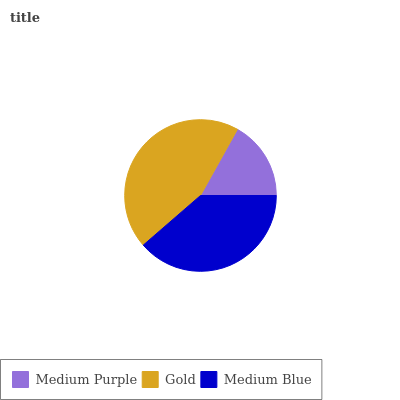Is Medium Purple the minimum?
Answer yes or no. Yes. Is Gold the maximum?
Answer yes or no. Yes. Is Medium Blue the minimum?
Answer yes or no. No. Is Medium Blue the maximum?
Answer yes or no. No. Is Gold greater than Medium Blue?
Answer yes or no. Yes. Is Medium Blue less than Gold?
Answer yes or no. Yes. Is Medium Blue greater than Gold?
Answer yes or no. No. Is Gold less than Medium Blue?
Answer yes or no. No. Is Medium Blue the high median?
Answer yes or no. Yes. Is Medium Blue the low median?
Answer yes or no. Yes. Is Gold the high median?
Answer yes or no. No. Is Gold the low median?
Answer yes or no. No. 